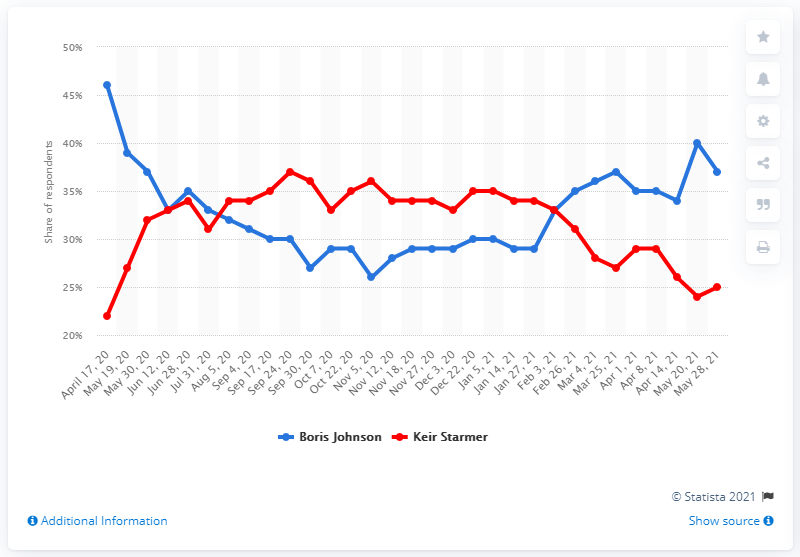Point out several critical features in this image. As of May 2021, 37% of people in Great Britain preferred Boris Johnson as their preferred Prime Minister, according to a survey. 